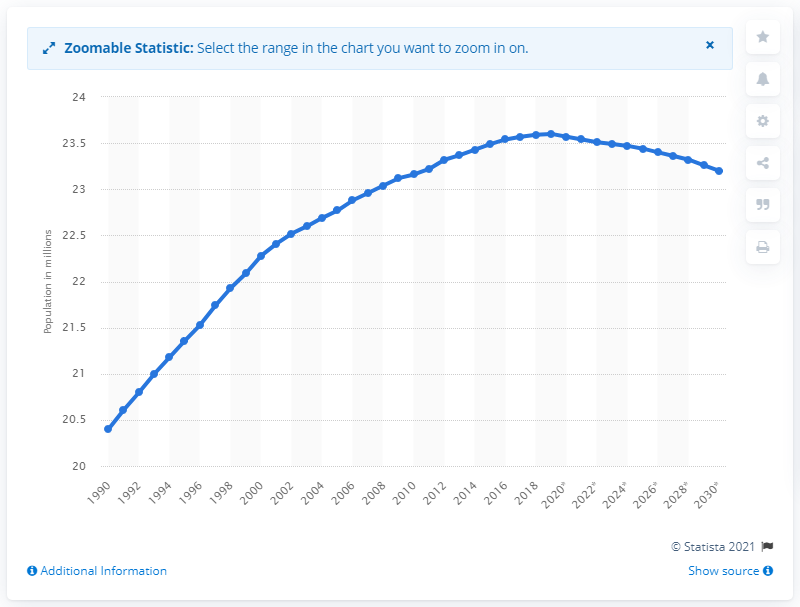Give some essential details in this illustration. As of 2019, the population of Taiwan was 23.4 million. 